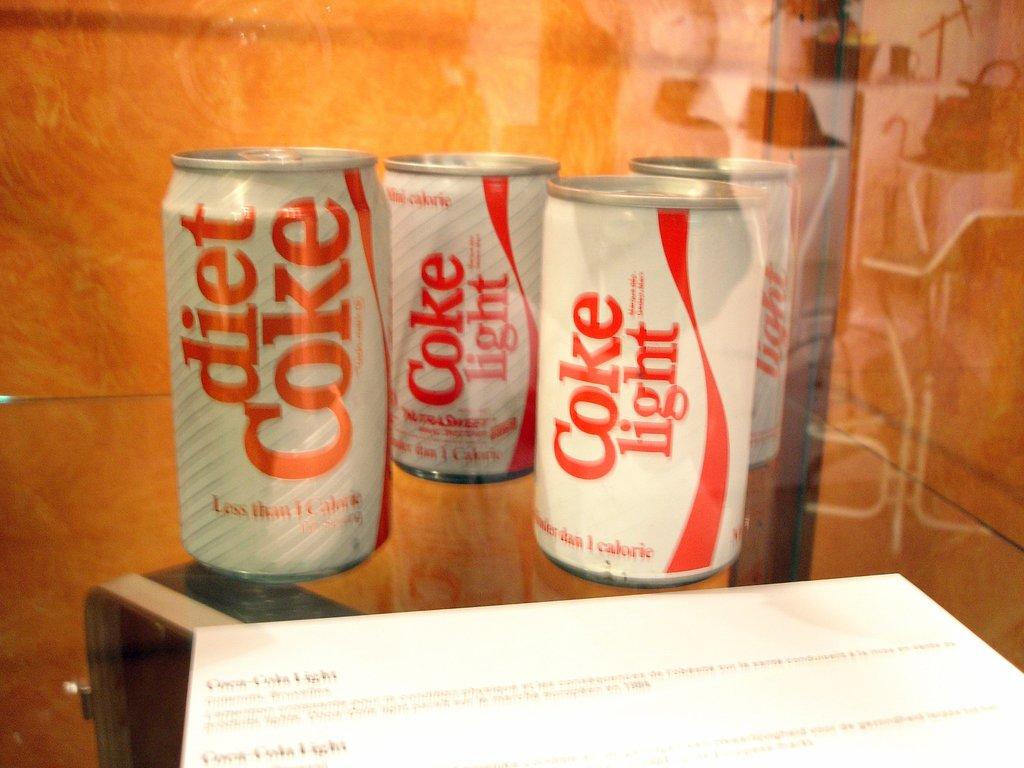Which flavor is the soda?
Make the answer very short. Diet coke. 